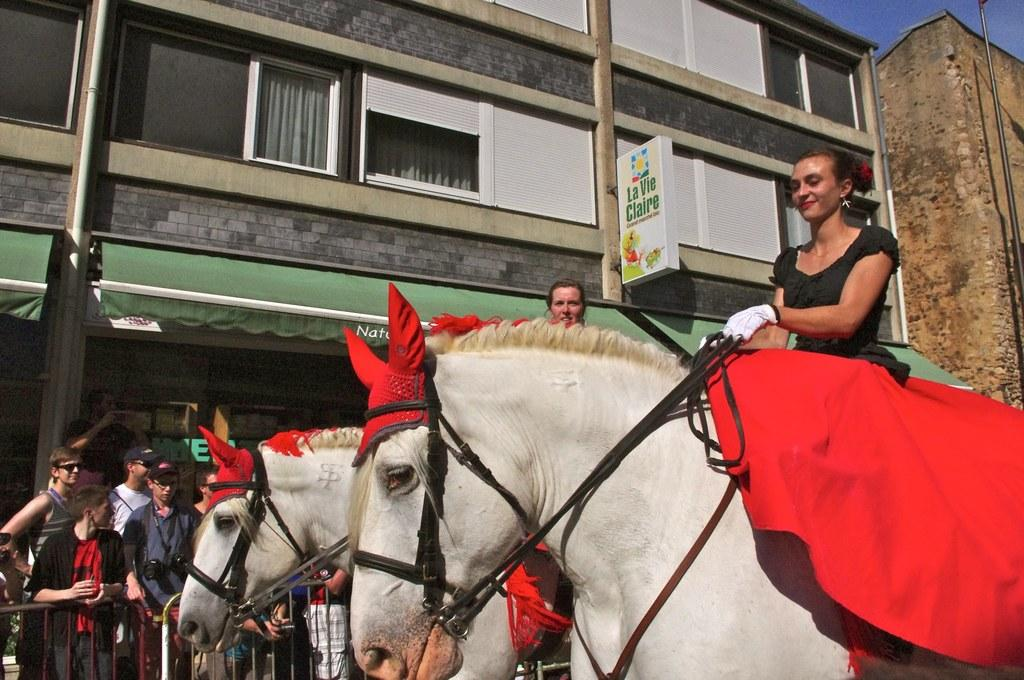Who or what can be seen in the image? There are people in the image. What are the people doing in the image? The people are sitting on horses. What structure is visible in the image? There is a building visible in the image. What position are the people in the image? The people are standing in the image. What type of insurance policy is being discussed by the people in the image? There is no indication in the image that the people are discussing any insurance policies. 